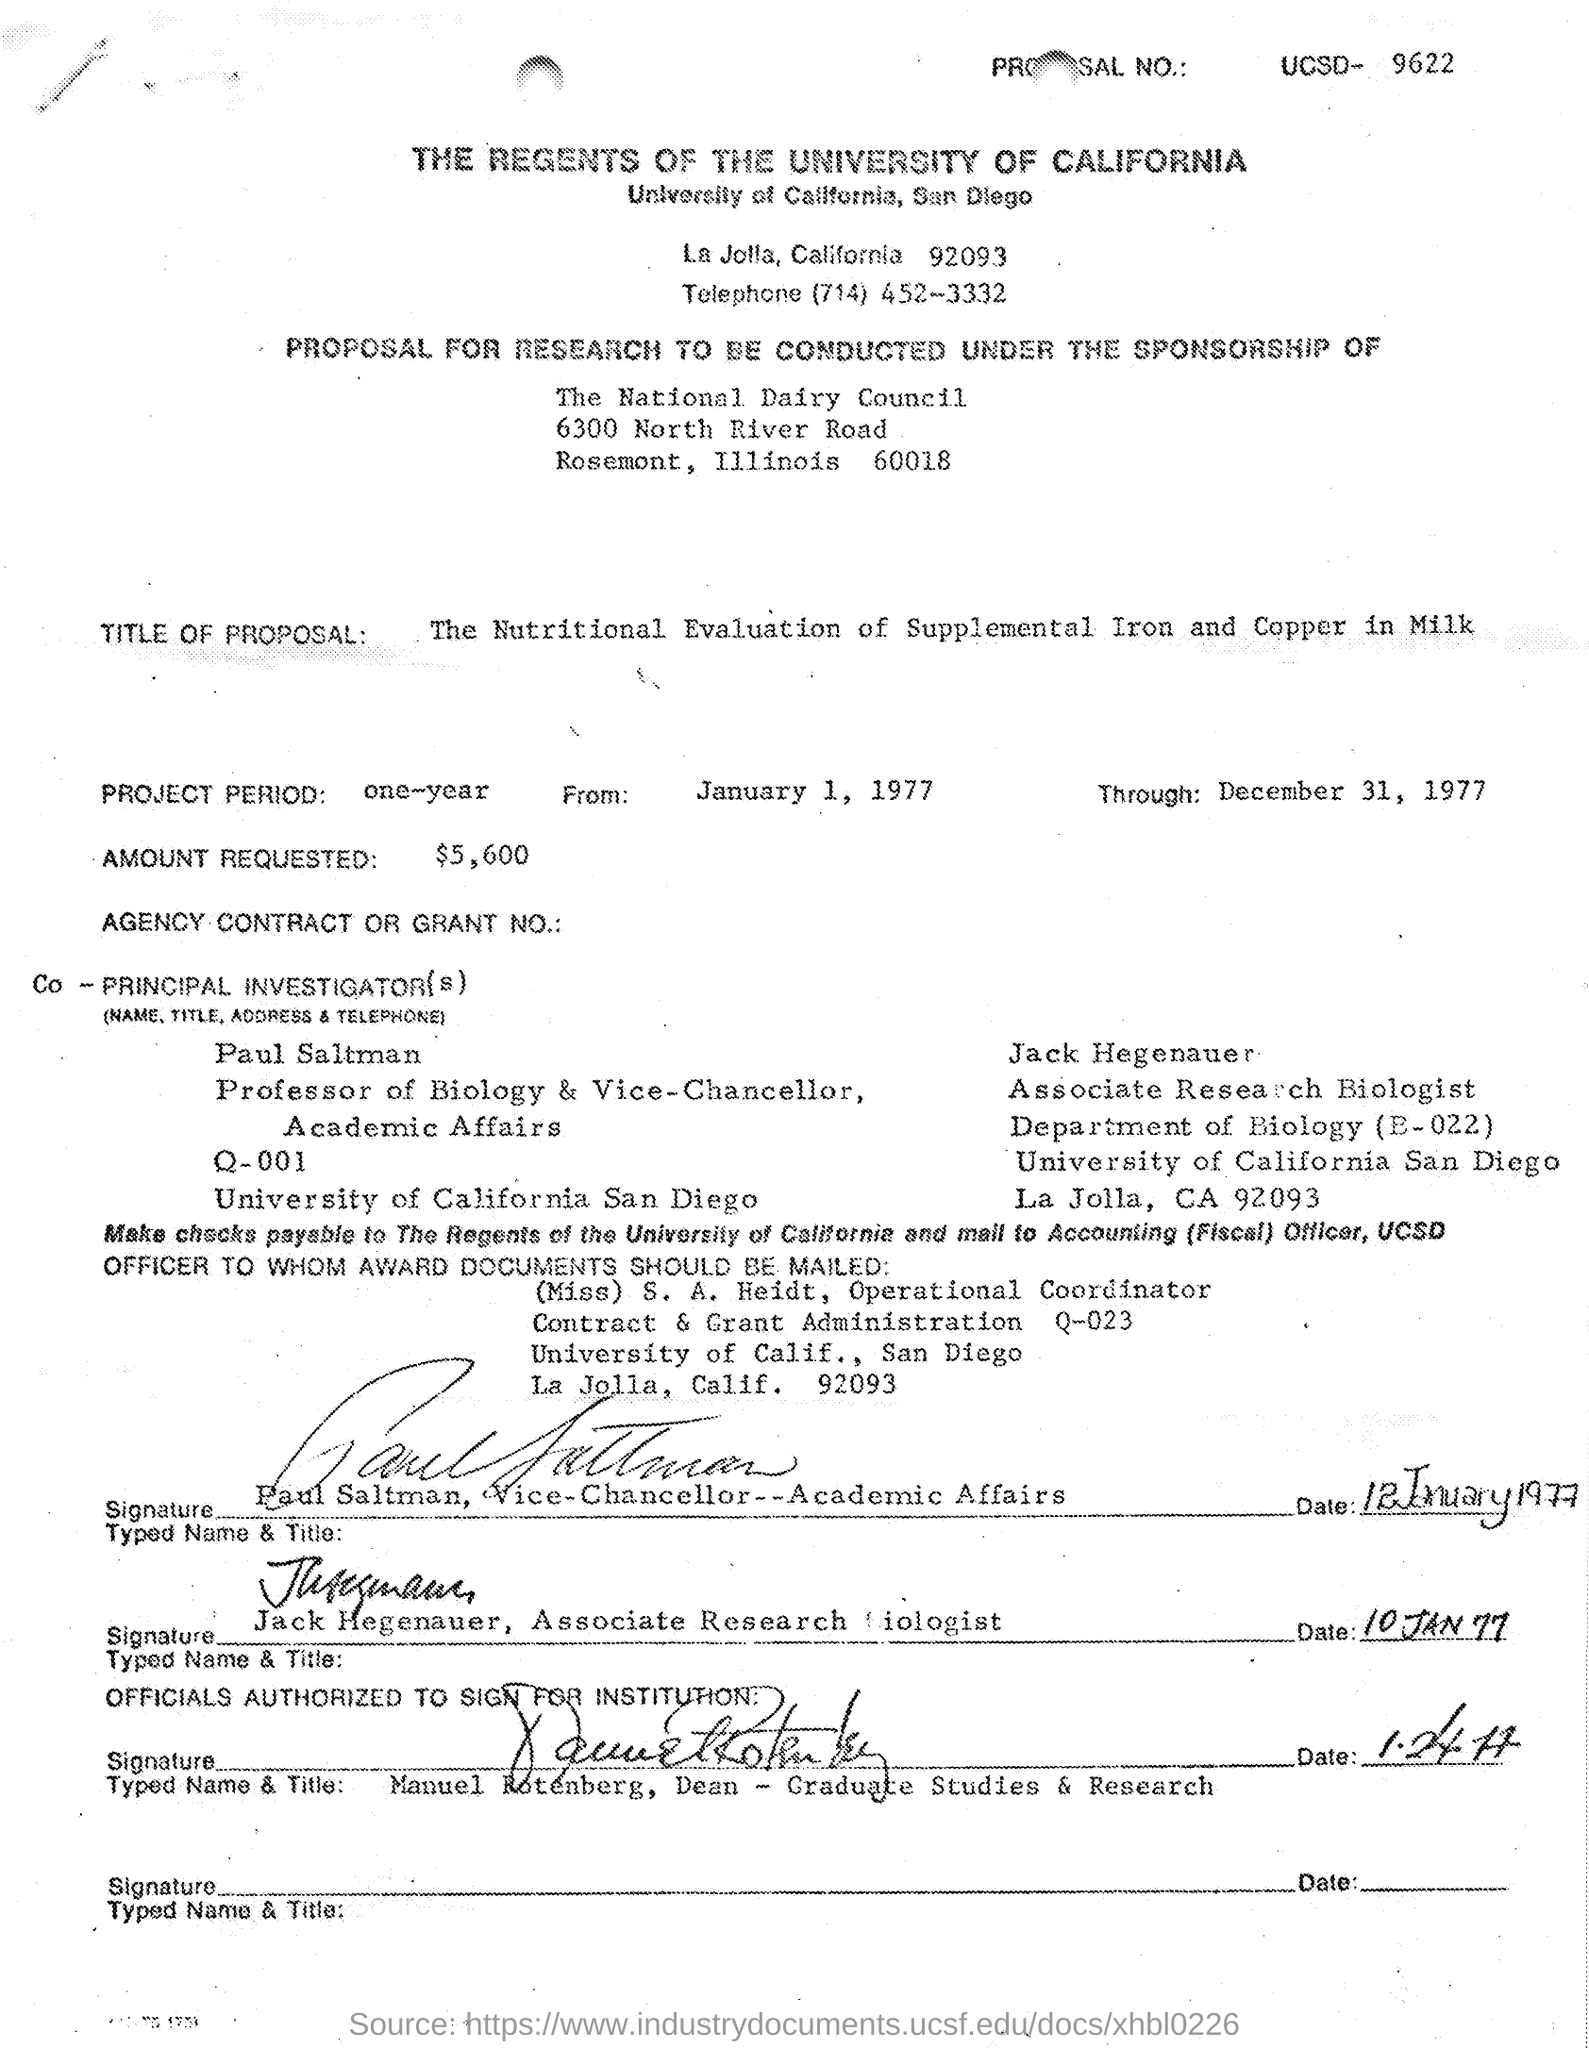Which Council is the sponsor of the Research?
Make the answer very short. The National Dairy Council. What is the title of the proposal?
Your answer should be compact. The Nutritional Evaluation of Supplemental Iron and Copper in Milk. How much is the amount requested?
Your response must be concise. $5600. 